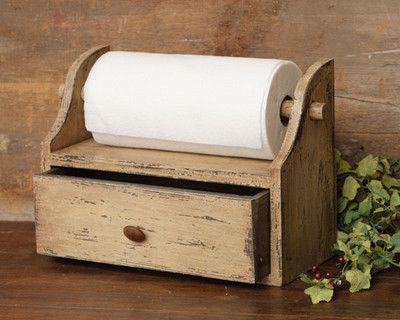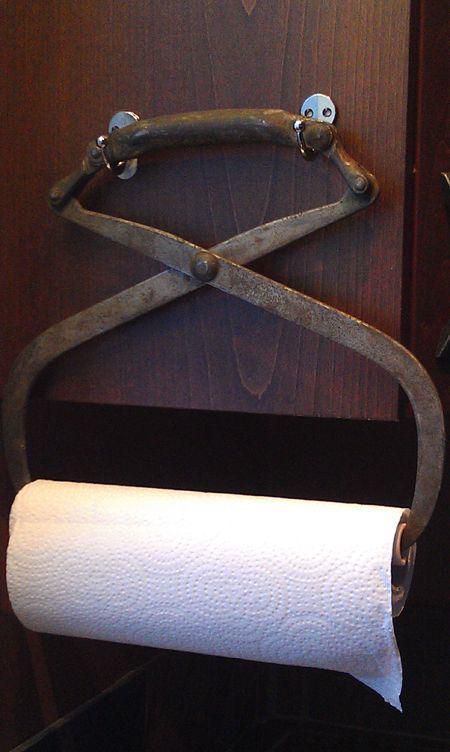The first image is the image on the left, the second image is the image on the right. For the images displayed, is the sentence "Each roll of paper towel is on a roller." factually correct? Answer yes or no. Yes. The first image is the image on the left, the second image is the image on the right. Examine the images to the left and right. Is the description "One of the images shows brown folded paper towels." accurate? Answer yes or no. No. 